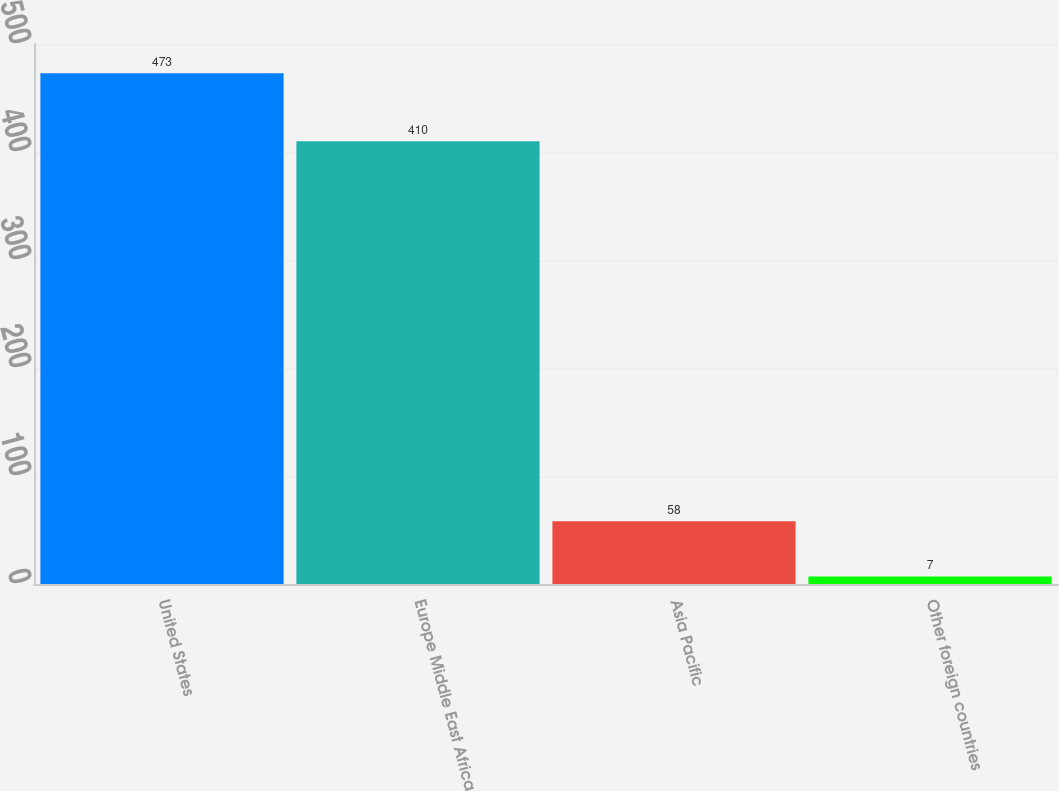Convert chart to OTSL. <chart><loc_0><loc_0><loc_500><loc_500><bar_chart><fcel>United States<fcel>Europe Middle East Africa<fcel>Asia Pacific<fcel>Other foreign countries<nl><fcel>473<fcel>410<fcel>58<fcel>7<nl></chart> 